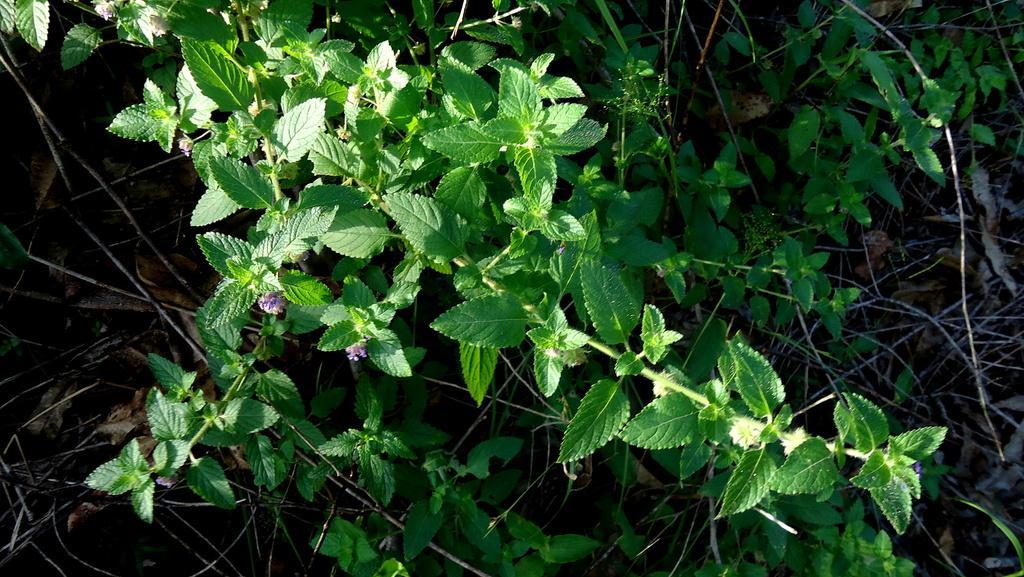Can you describe this image briefly? In this image we can see plants with flowers. 